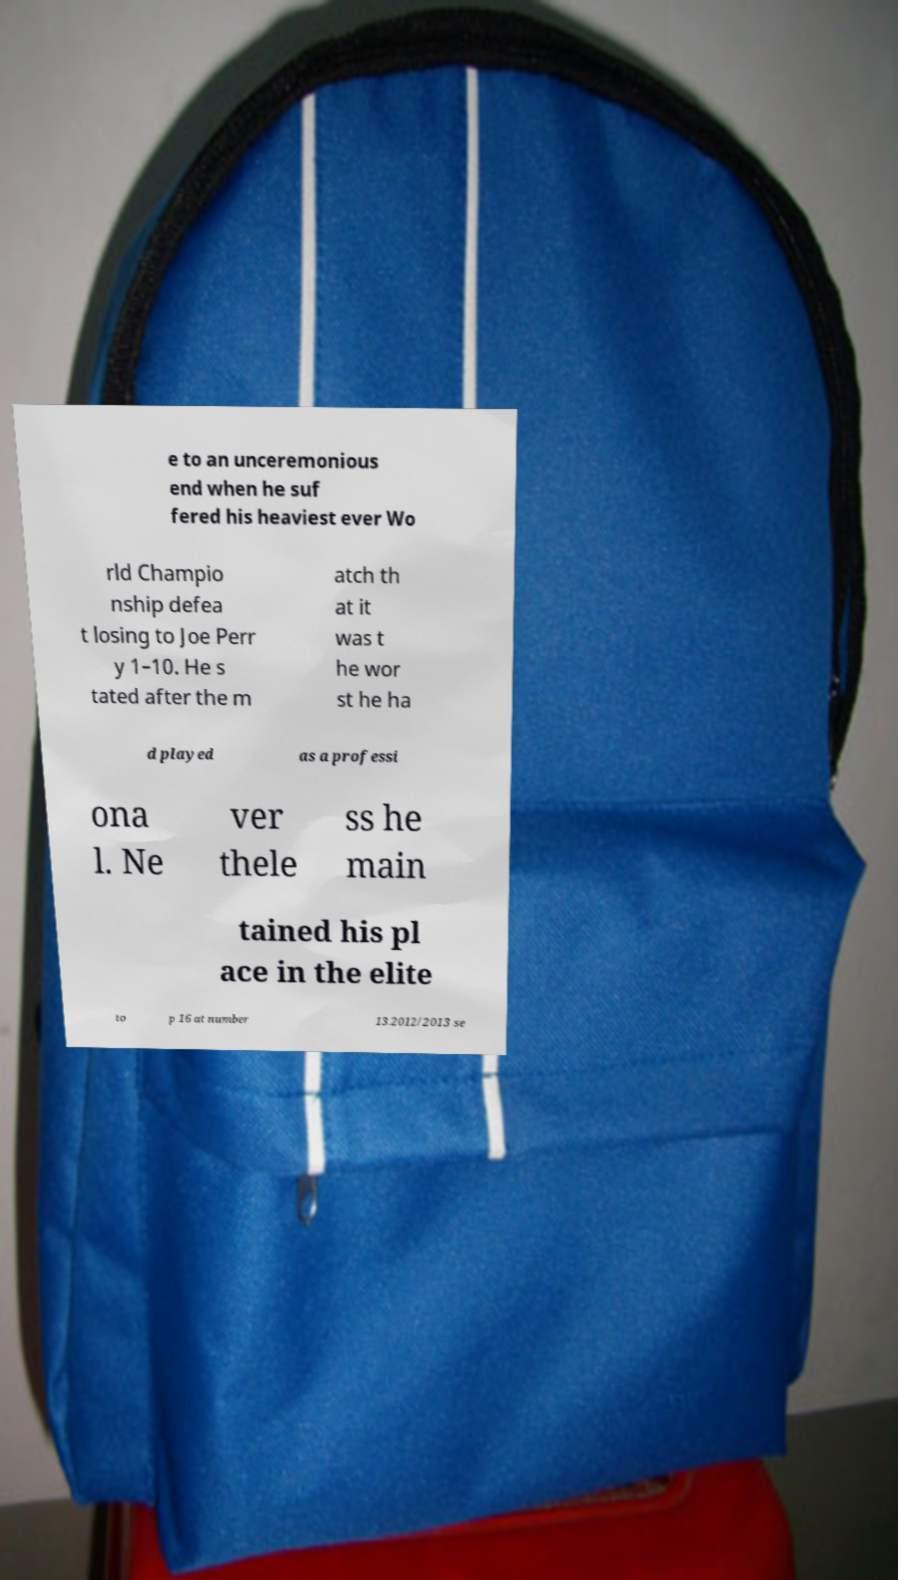Can you accurately transcribe the text from the provided image for me? e to an unceremonious end when he suf fered his heaviest ever Wo rld Champio nship defea t losing to Joe Perr y 1–10. He s tated after the m atch th at it was t he wor st he ha d played as a professi ona l. Ne ver thele ss he main tained his pl ace in the elite to p 16 at number 13.2012/2013 se 